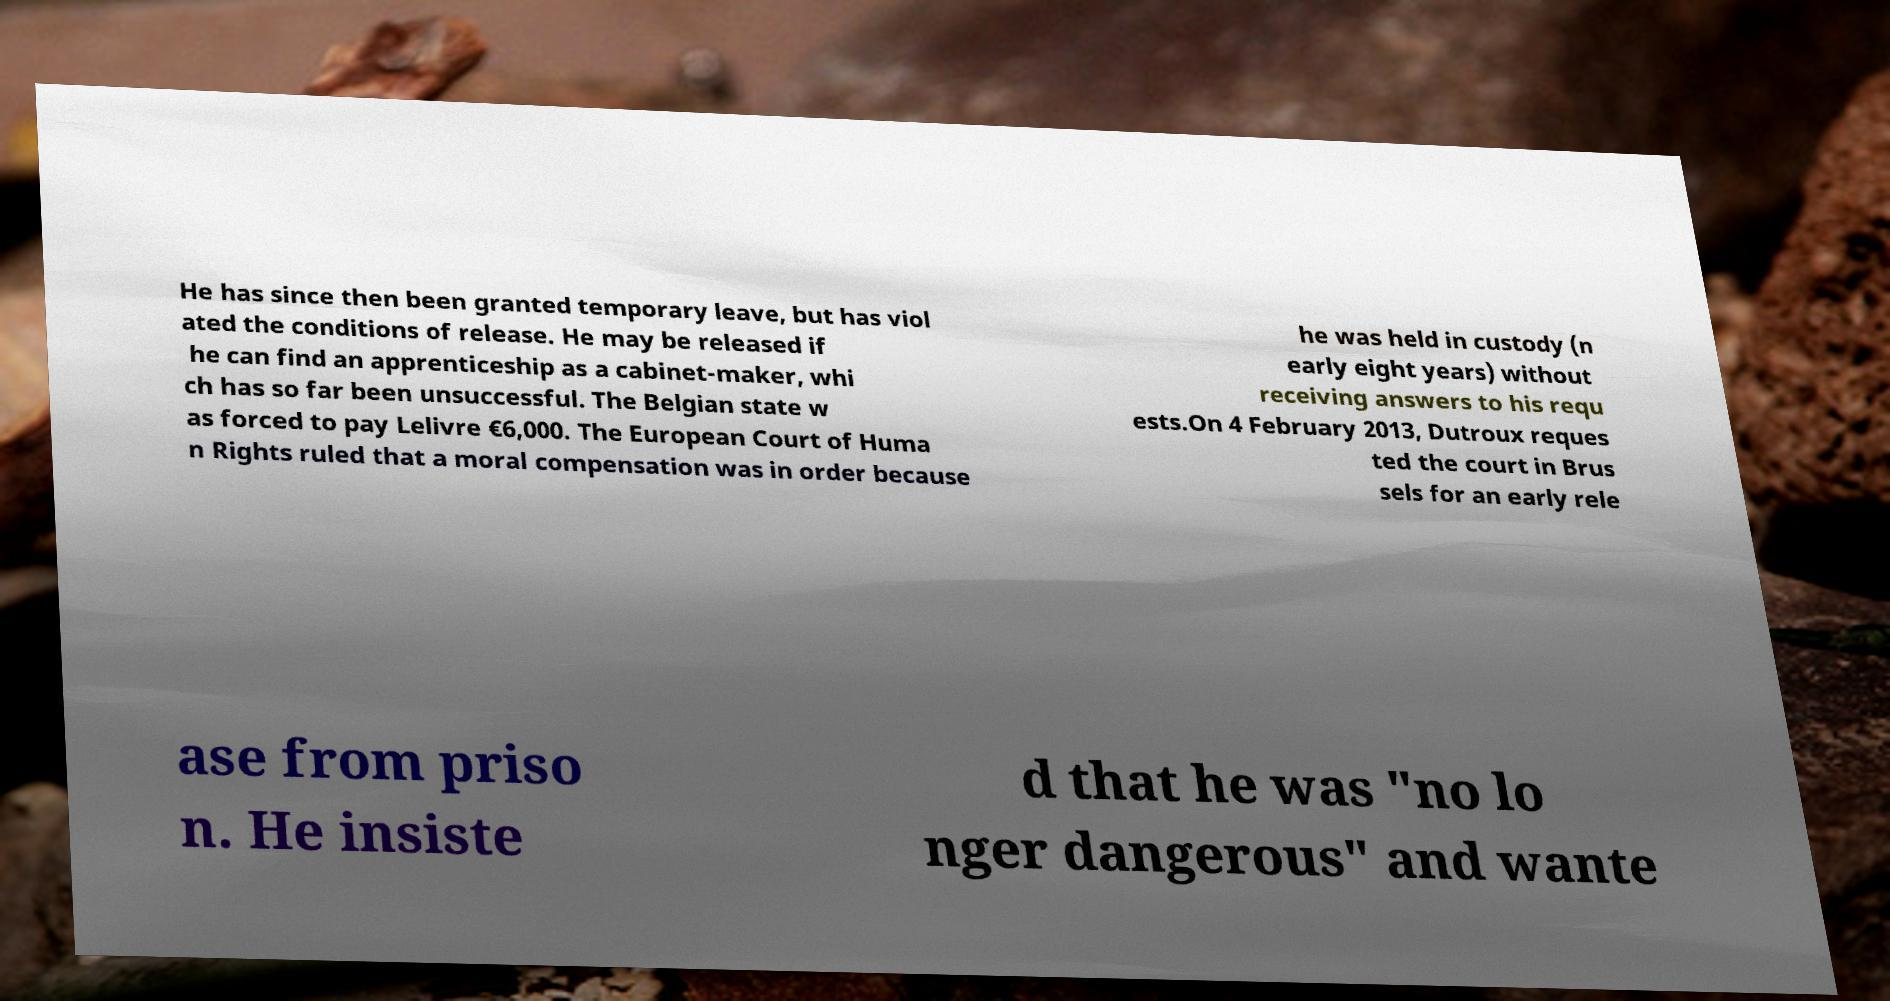Could you extract and type out the text from this image? He has since then been granted temporary leave, but has viol ated the conditions of release. He may be released if he can find an apprenticeship as a cabinet-maker, whi ch has so far been unsuccessful. The Belgian state w as forced to pay Lelivre €6,000. The European Court of Huma n Rights ruled that a moral compensation was in order because he was held in custody (n early eight years) without receiving answers to his requ ests.On 4 February 2013, Dutroux reques ted the court in Brus sels for an early rele ase from priso n. He insiste d that he was "no lo nger dangerous" and wante 